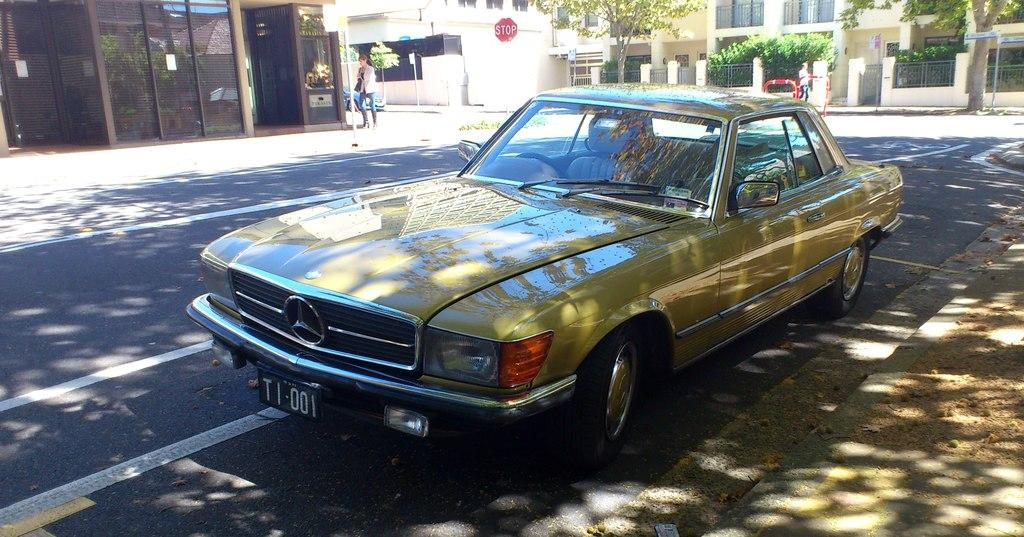What type of vehicle is on the road in the image? There is a motor vehicle on the road in the image. What are the people on the side of the road doing? There are persons walking on the footpath in the image. What structures can be seen in the background of the image? There are buildings in the image. What other objects are present along the road? Street poles are present in the image. What type of vegetation is visible in the image? Trees are visible in the image. What type of information might be conveyed by the sign board in the image? There is a sign board in the image, which might convey information such as directions, warnings, or advertisements. Where is the grandmother sitting in the image? There is no grandmother present in the image. What type of surprise can be seen in the image? There is no surprise present in the image. 